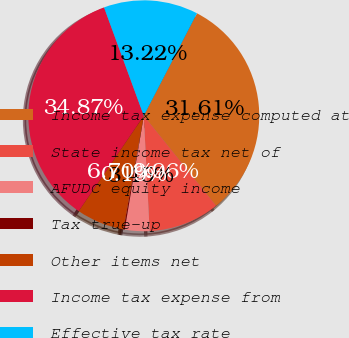Convert chart to OTSL. <chart><loc_0><loc_0><loc_500><loc_500><pie_chart><fcel>Income tax expense computed at<fcel>State income tax net of<fcel>AFUDC equity income<fcel>Tax true-up<fcel>Other items net<fcel>Income tax expense from<fcel>Effective tax rate<nl><fcel>31.61%<fcel>9.96%<fcel>3.45%<fcel>0.19%<fcel>6.7%<fcel>34.87%<fcel>13.22%<nl></chart> 